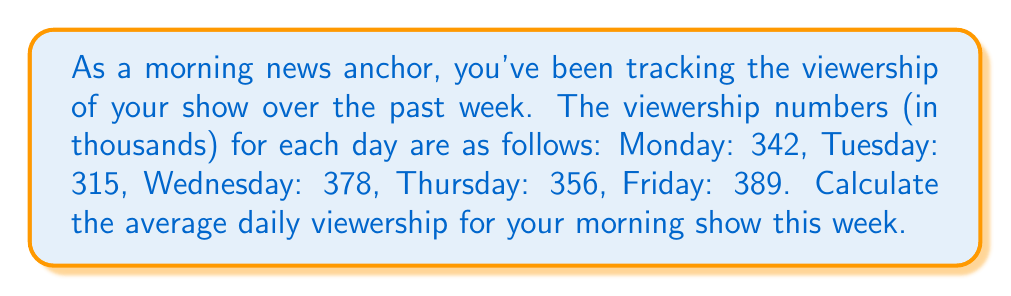Show me your answer to this math problem. To calculate the average daily viewership, we need to follow these steps:

1. Sum up the viewership numbers for all days:
   $$ S = 342 + 315 + 378 + 356 + 389 $$

2. Count the total number of days:
   $$ n = 5 $$

3. Apply the formula for arithmetic mean:
   $$ \text{Average} = \frac{\text{Sum of all terms}}{\text{Number of terms}} = \frac{S}{n} $$

Let's perform the calculations:

1. Sum of viewership:
   $$ S = 342 + 315 + 378 + 356 + 389 = 1780 $$

2. Number of days: $n = 5$

3. Average viewership:
   $$ \text{Average} = \frac{S}{n} = \frac{1780}{5} = 356 $$

Therefore, the average daily viewership for your morning show this week is 356 thousand viewers.
Answer: $356,000$ viewers 